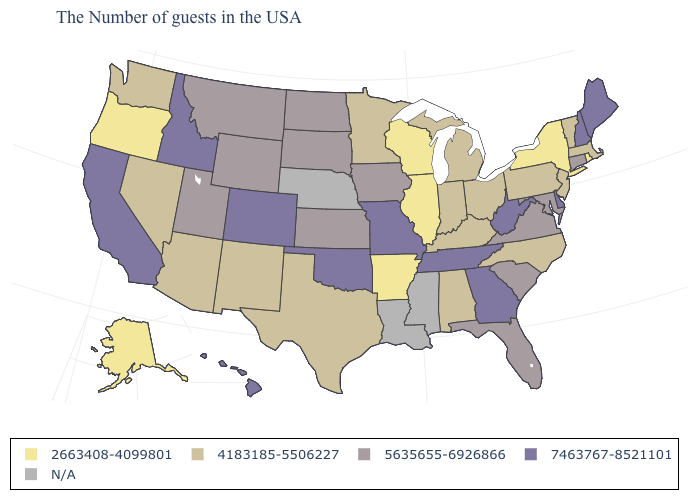Name the states that have a value in the range 2663408-4099801?
Give a very brief answer. Rhode Island, New York, Wisconsin, Illinois, Arkansas, Oregon, Alaska. What is the value of Nevada?
Short answer required. 4183185-5506227. What is the highest value in the USA?
Concise answer only. 7463767-8521101. What is the value of Rhode Island?
Quick response, please. 2663408-4099801. What is the lowest value in the South?
Give a very brief answer. 2663408-4099801. Name the states that have a value in the range 5635655-6926866?
Be succinct. Connecticut, Maryland, Virginia, South Carolina, Florida, Iowa, Kansas, South Dakota, North Dakota, Wyoming, Utah, Montana. Name the states that have a value in the range 7463767-8521101?
Write a very short answer. Maine, New Hampshire, Delaware, West Virginia, Georgia, Tennessee, Missouri, Oklahoma, Colorado, Idaho, California, Hawaii. What is the value of Nevada?
Keep it brief. 4183185-5506227. Among the states that border North Dakota , which have the highest value?
Concise answer only. South Dakota, Montana. Name the states that have a value in the range 2663408-4099801?
Answer briefly. Rhode Island, New York, Wisconsin, Illinois, Arkansas, Oregon, Alaska. What is the value of Colorado?
Keep it brief. 7463767-8521101. Among the states that border Georgia , does Florida have the highest value?
Short answer required. No. What is the lowest value in states that border Ohio?
Concise answer only. 4183185-5506227. What is the lowest value in the West?
Short answer required. 2663408-4099801. Does the first symbol in the legend represent the smallest category?
Quick response, please. Yes. 